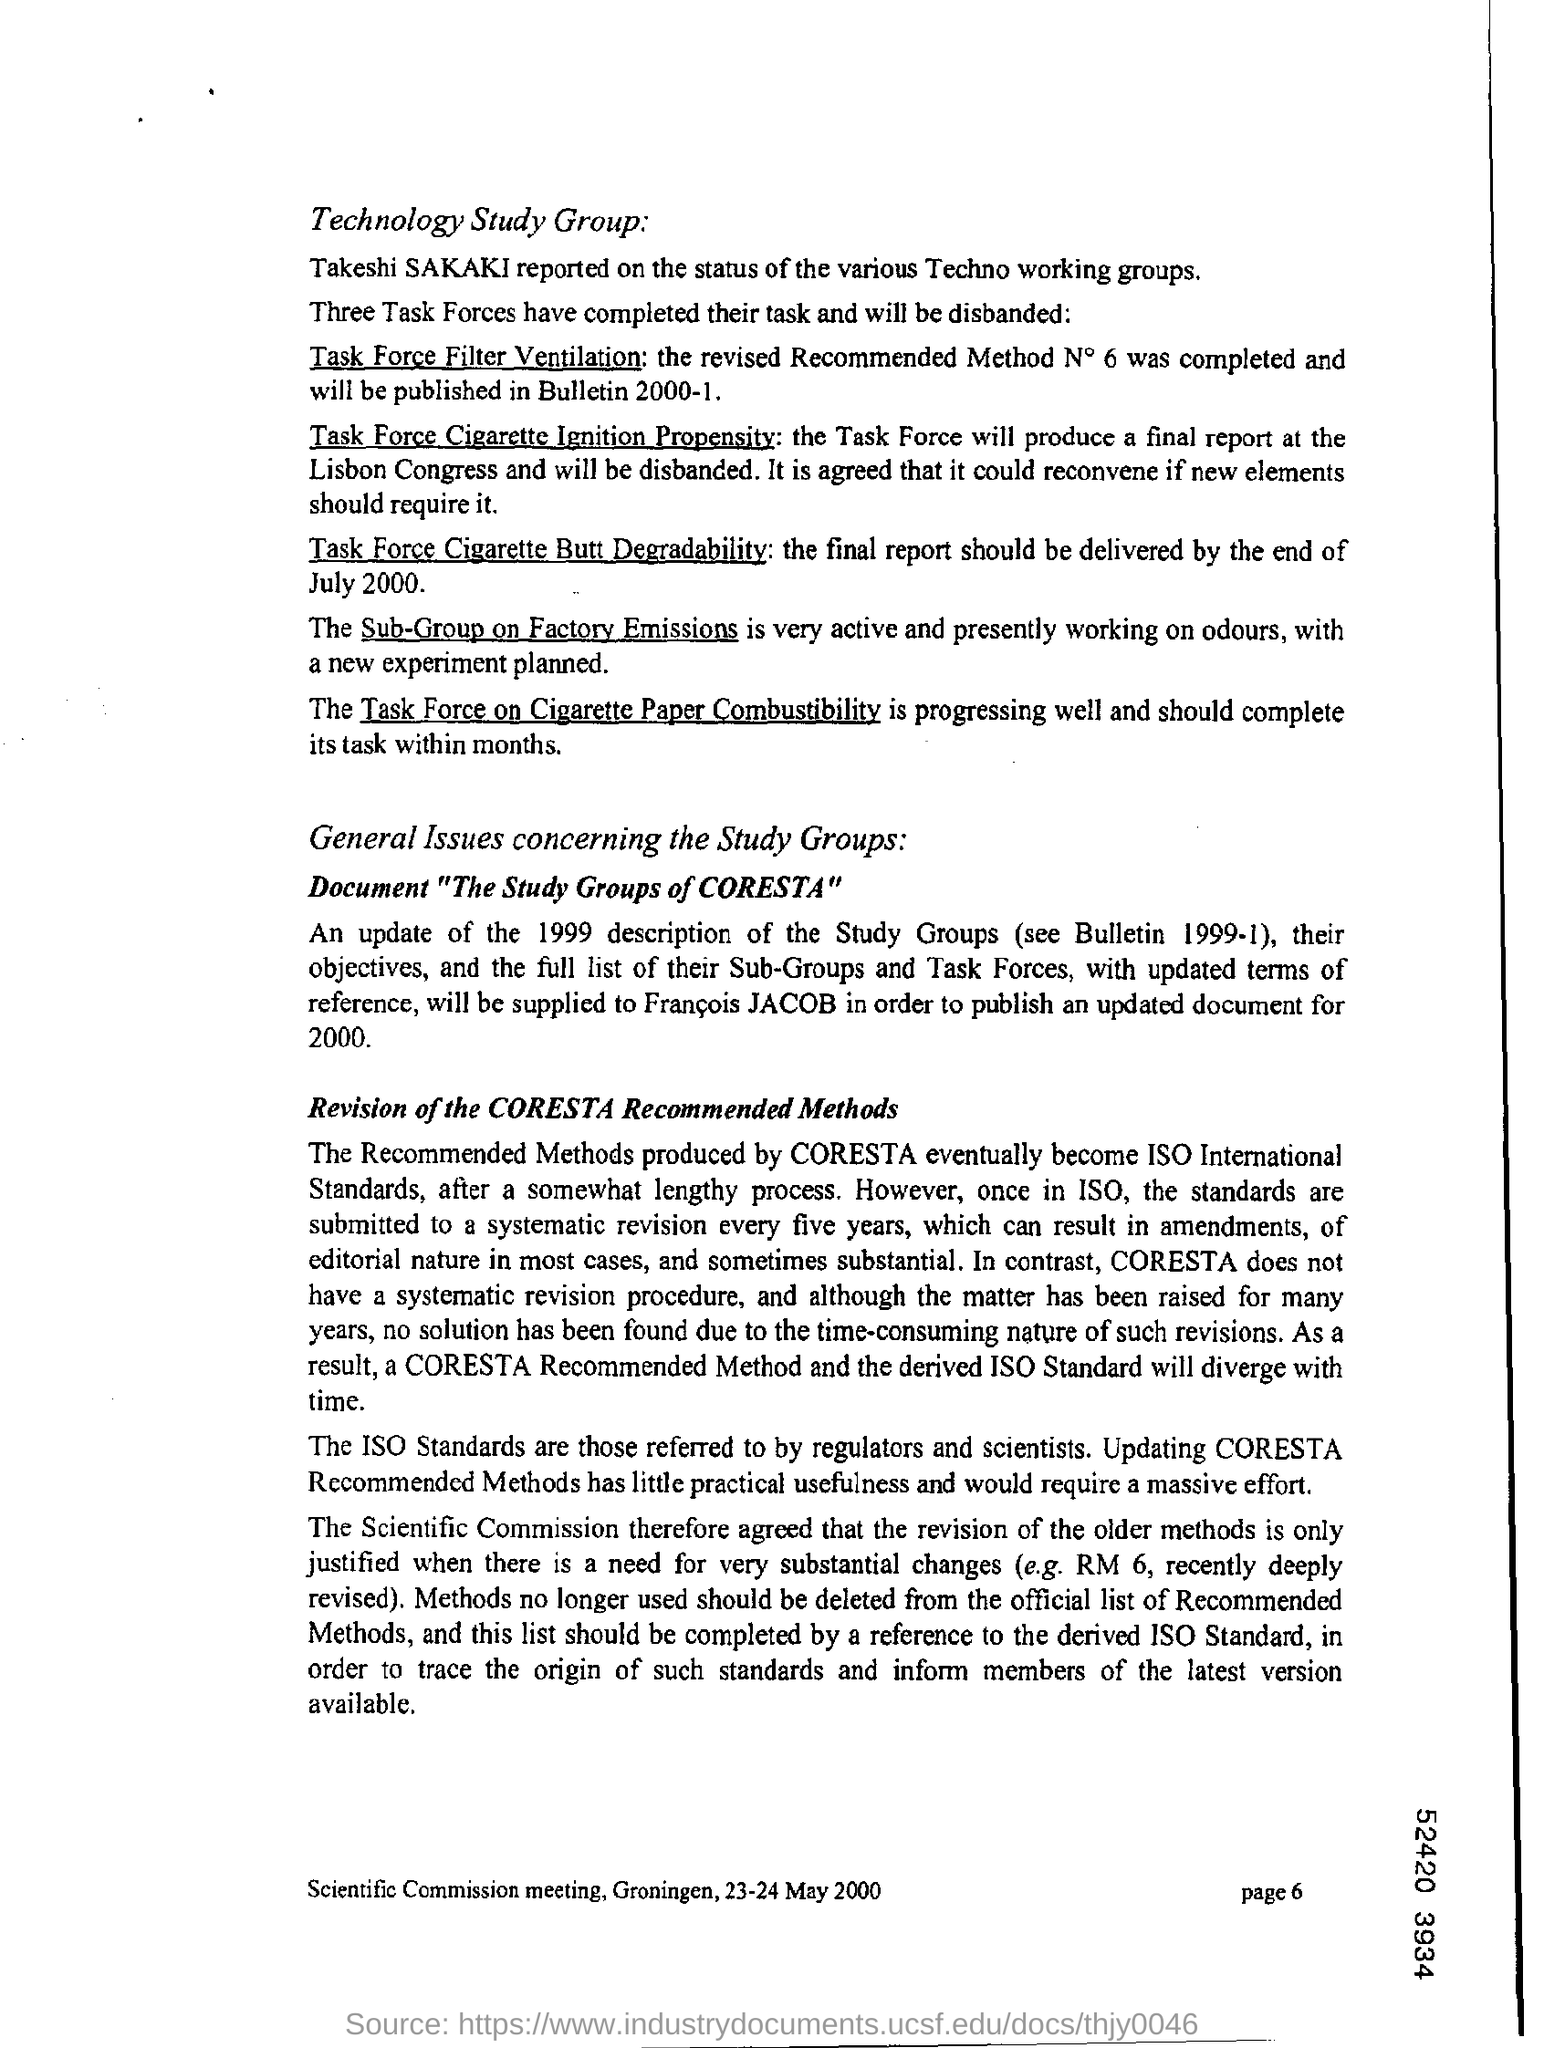Mention page number at bottom right corner of page ?
Ensure brevity in your answer.  Page 6. 